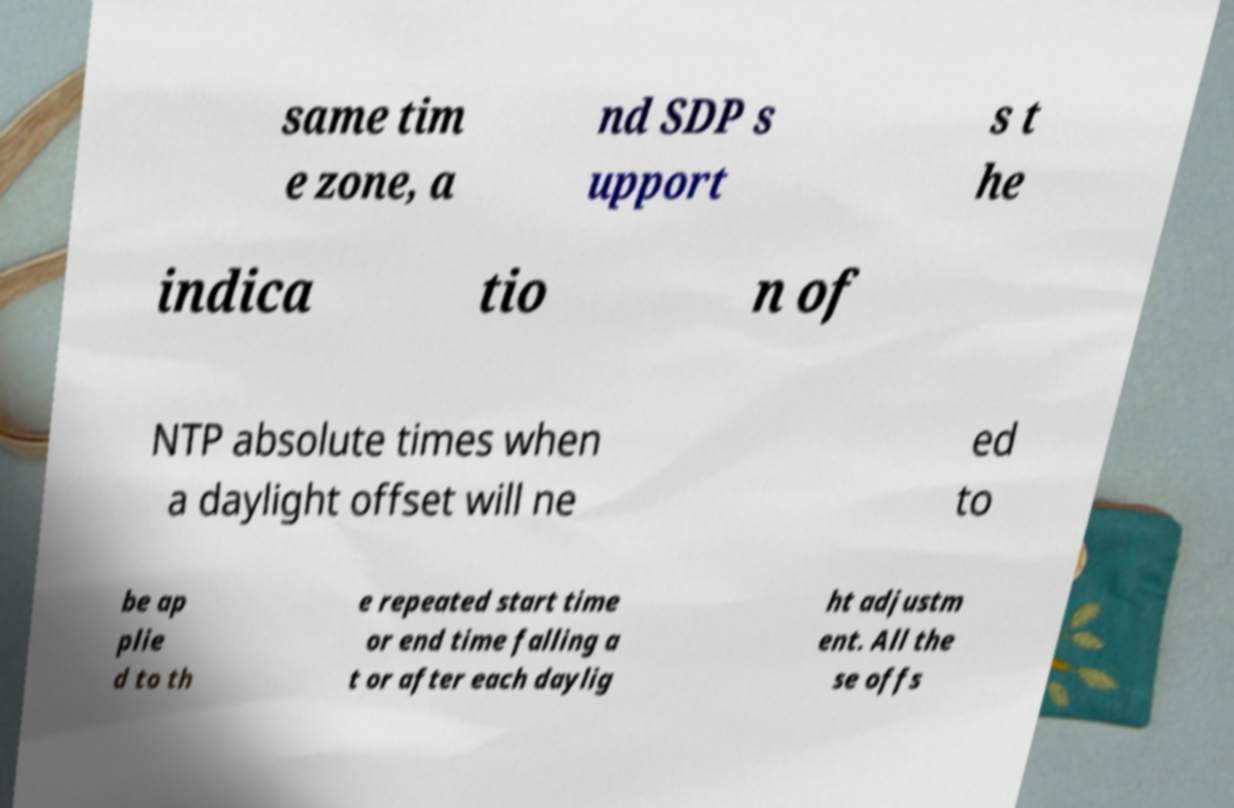Could you assist in decoding the text presented in this image and type it out clearly? same tim e zone, a nd SDP s upport s t he indica tio n of NTP absolute times when a daylight offset will ne ed to be ap plie d to th e repeated start time or end time falling a t or after each daylig ht adjustm ent. All the se offs 